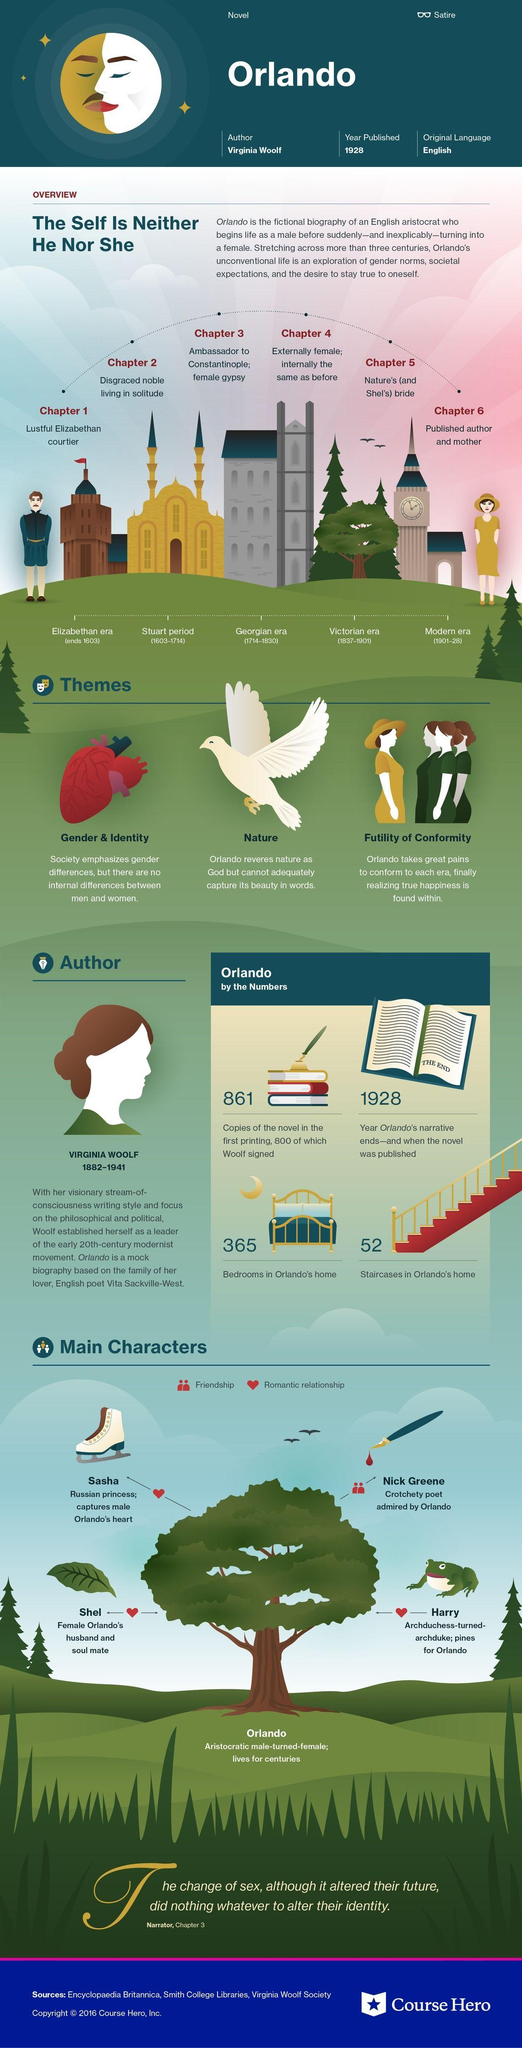Outline some significant characteristics in this image. The 5th chapter of Orlando is about nature and its bride, specifically Shel, who is a symbol of the natural world. Orlando and Nick were friends. The main characters who had romantic relationships with Orlando are Sasha, Harry, and Shel. Virginia Woolf passed away in 1941. The narration of "modern era" in the novel "Orlando" ended in 1928. 